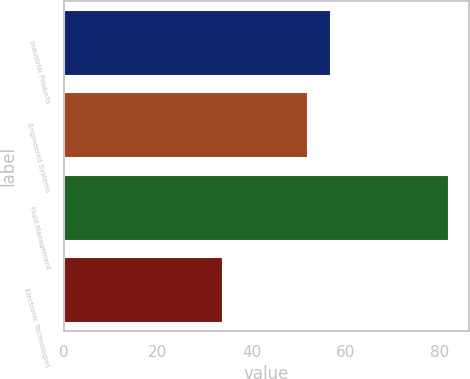<chart> <loc_0><loc_0><loc_500><loc_500><bar_chart><fcel>Industrial Products<fcel>Engineered Systems<fcel>Fluid Management<fcel>Electronic Technologies<nl><fcel>56.8<fcel>52<fcel>82<fcel>34<nl></chart> 